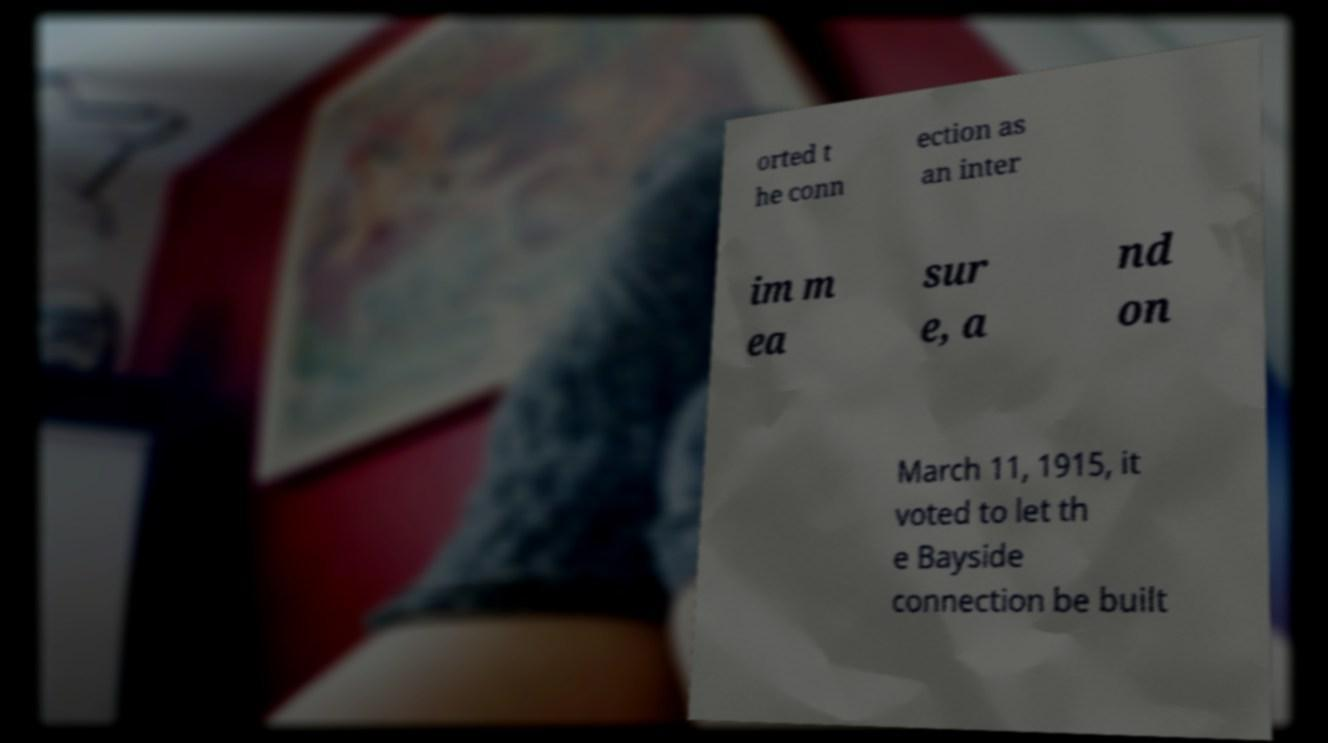Please identify and transcribe the text found in this image. orted t he conn ection as an inter im m ea sur e, a nd on March 11, 1915, it voted to let th e Bayside connection be built 